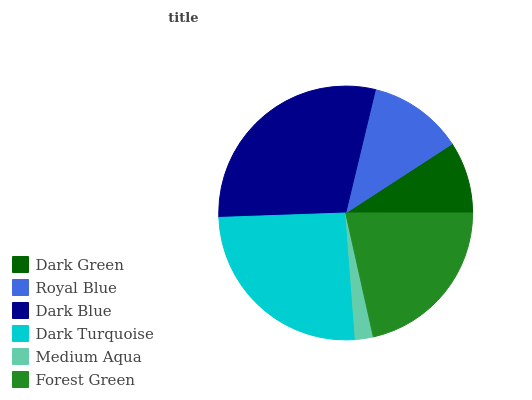Is Medium Aqua the minimum?
Answer yes or no. Yes. Is Dark Blue the maximum?
Answer yes or no. Yes. Is Royal Blue the minimum?
Answer yes or no. No. Is Royal Blue the maximum?
Answer yes or no. No. Is Royal Blue greater than Dark Green?
Answer yes or no. Yes. Is Dark Green less than Royal Blue?
Answer yes or no. Yes. Is Dark Green greater than Royal Blue?
Answer yes or no. No. Is Royal Blue less than Dark Green?
Answer yes or no. No. Is Forest Green the high median?
Answer yes or no. Yes. Is Royal Blue the low median?
Answer yes or no. Yes. Is Dark Blue the high median?
Answer yes or no. No. Is Dark Green the low median?
Answer yes or no. No. 